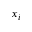<formula> <loc_0><loc_0><loc_500><loc_500>x _ { i }</formula> 